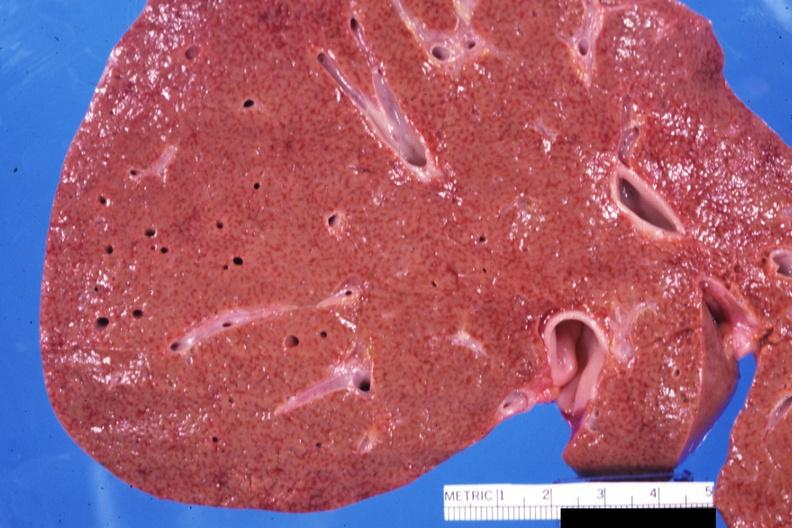s hepatobiliary present?
Answer the question using a single word or phrase. Yes 